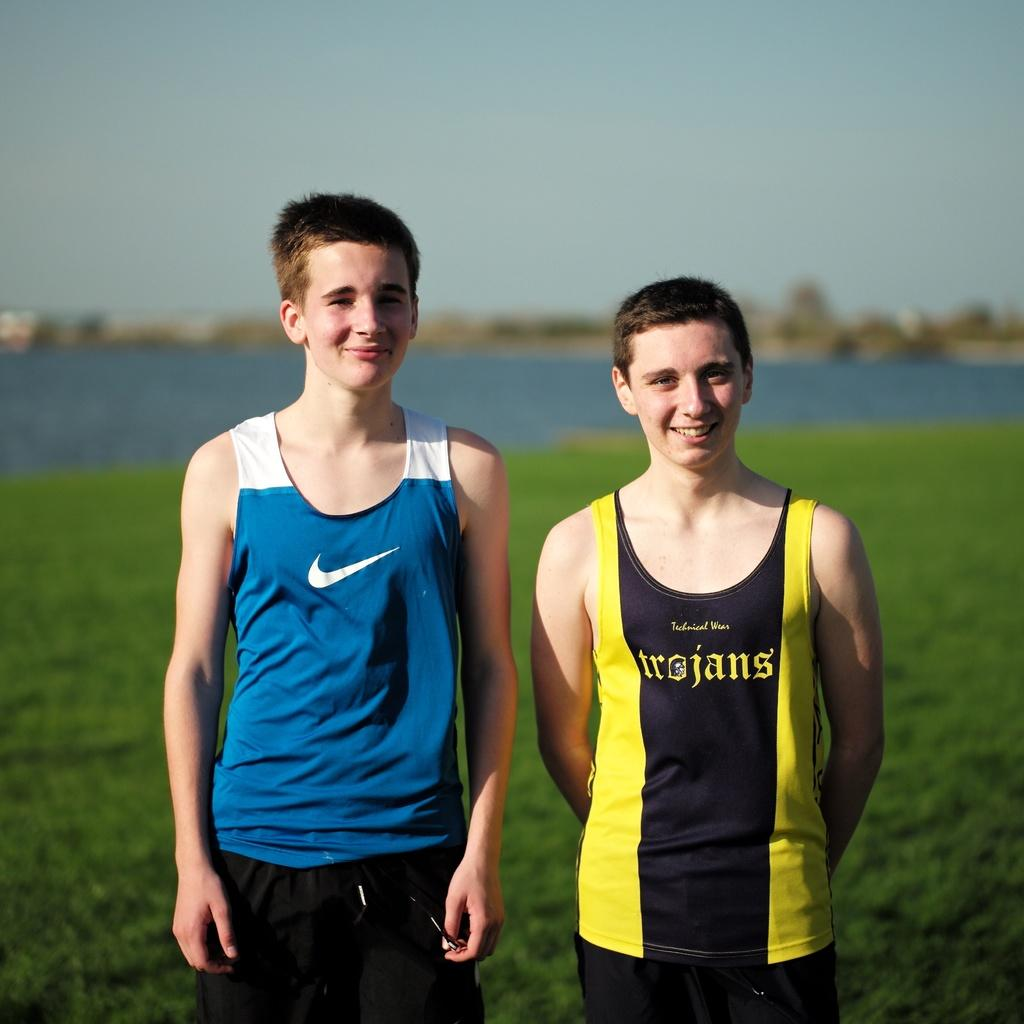<image>
Relay a brief, clear account of the picture shown. Two boys in a Nike and a trojans track jersey. 